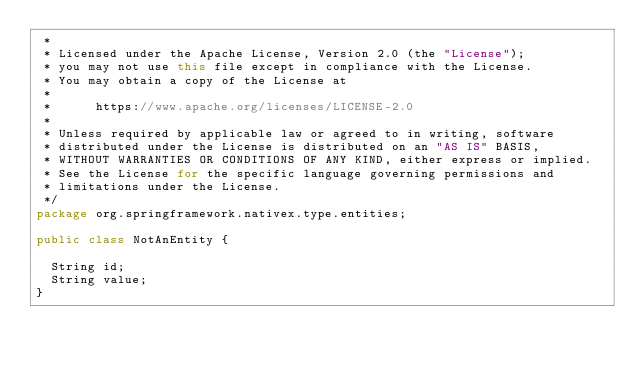<code> <loc_0><loc_0><loc_500><loc_500><_Java_> *
 * Licensed under the Apache License, Version 2.0 (the "License");
 * you may not use this file except in compliance with the License.
 * You may obtain a copy of the License at
 *
 *      https://www.apache.org/licenses/LICENSE-2.0
 *
 * Unless required by applicable law or agreed to in writing, software
 * distributed under the License is distributed on an "AS IS" BASIS,
 * WITHOUT WARRANTIES OR CONDITIONS OF ANY KIND, either express or implied.
 * See the License for the specific language governing permissions and
 * limitations under the License.
 */
package org.springframework.nativex.type.entities;

public class NotAnEntity {

	String id;
	String value;
}
</code> 